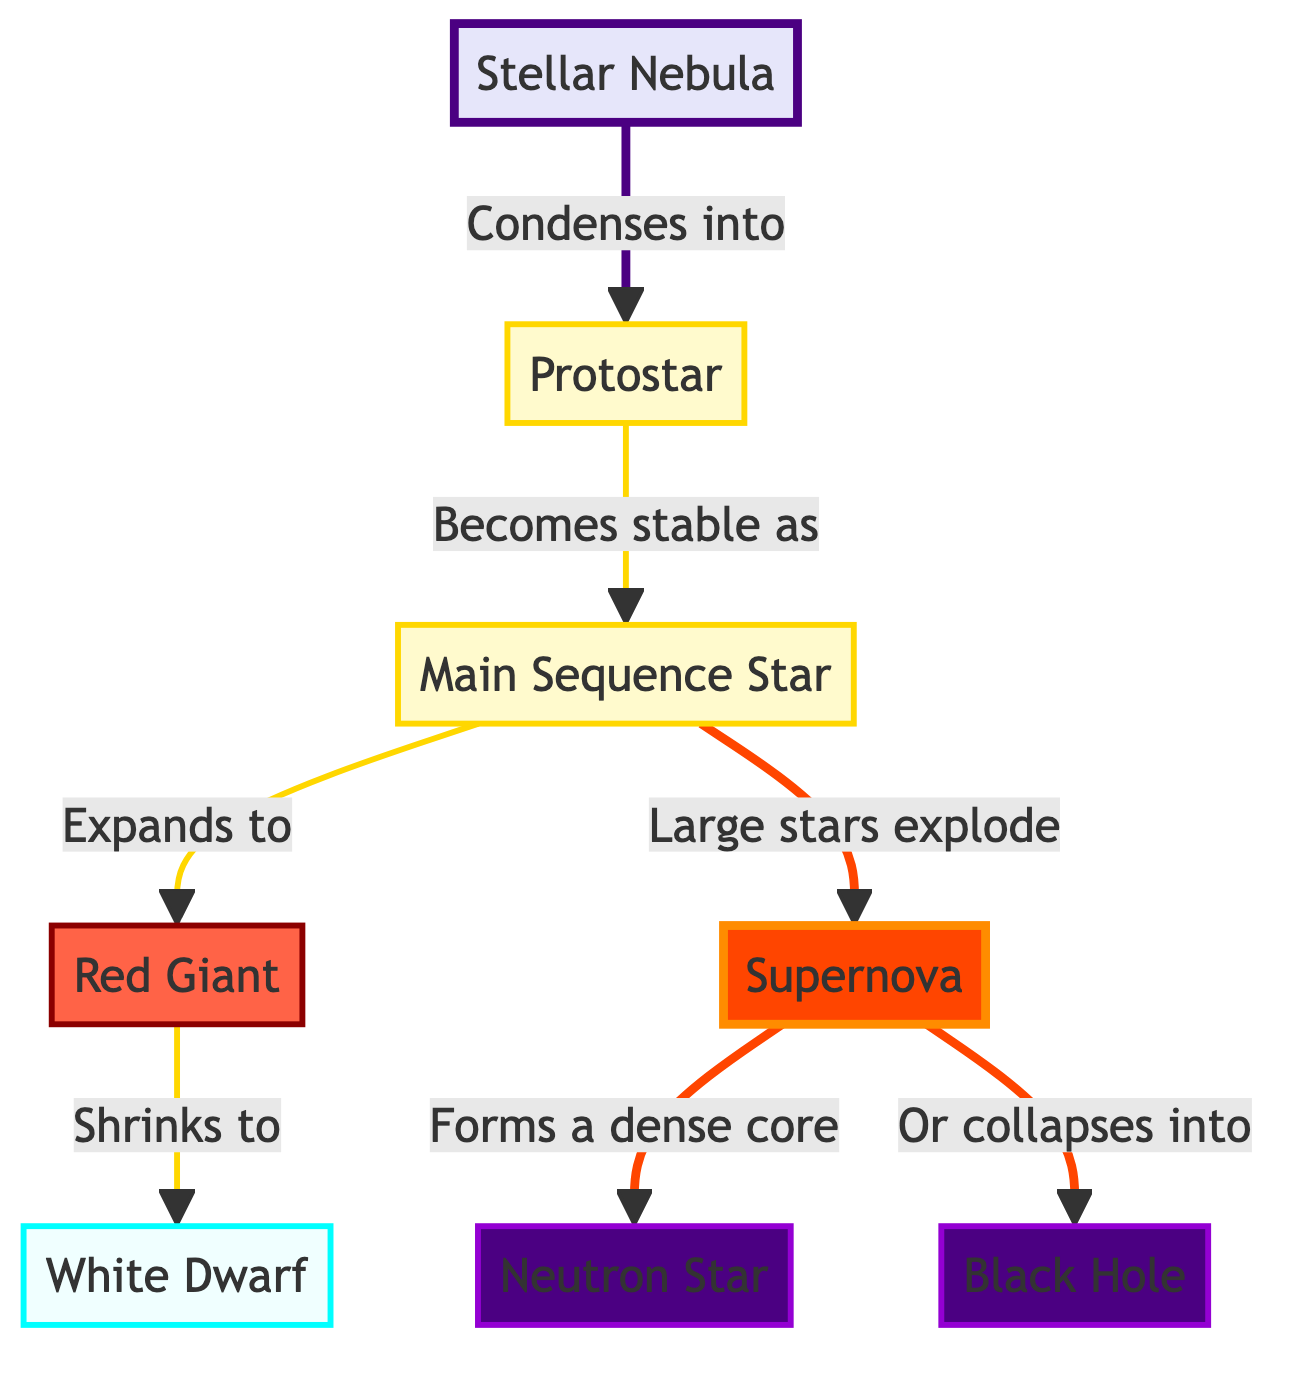What is the first stage of stellar evolution shown in the diagram? The diagram starts with the node labeled "Stellar Nebula," indicating it is the first stage in the process of stellar evolution.
Answer: Stellar Nebula Which star type expands to become a Red Giant? The diagram shows that the "Main Sequence Star" expands to become a "Red Giant," establishing the relationship between these two stages.
Answer: Main Sequence Star How many types of dense stars are represented in the diagram? The diagram includes two types of dense stars, which are "Neutron Star" and "Black Hole," making a total of two types.
Answer: 2 What event occurs after a Large Star explodes? Following the explosion of a Large Star represented as "Main Sequence Star," it leads to a "Supernova," showcasing the process that follows the explosion.
Answer: Supernova What is the final form of a star that has exploded as indicated in the diagram? The diagram indicates that after a "Supernova," a dense core forms either into a "Neutron Star" or collapses into a "Black Hole," representing the final forms of such stars post-explosion.
Answer: Neutron Star or Black Hole What process occurs between the Protostar and the Main Sequence Star? The diagram suggests that the transition from a "Protostar" to a "Main Sequence Star" involves the Protostar becoming stable, which describes the key process occurring at this stage.
Answer: Becomes stable What color signifies a Giant Star in the diagram? The diagram uses a red color (#ff6347) to denote a "Red Giant," visually representing this type's classification within the flowchart.
Answer: Red What happens after a star shrinks down to a White Dwarf? After a Star shrinks down to a "White Dwarf," there is no further process indicated in the diagram, meaning it represents an endpoint in this evolutionary sequence.
Answer: None How does a Stellar Nebula transform into a Protostar? The "Stellar Nebula" condenses into a "Protostar," which is displayed in the diagram as a direct flow from the start to the subsequent stage.
Answer: Condenses into 